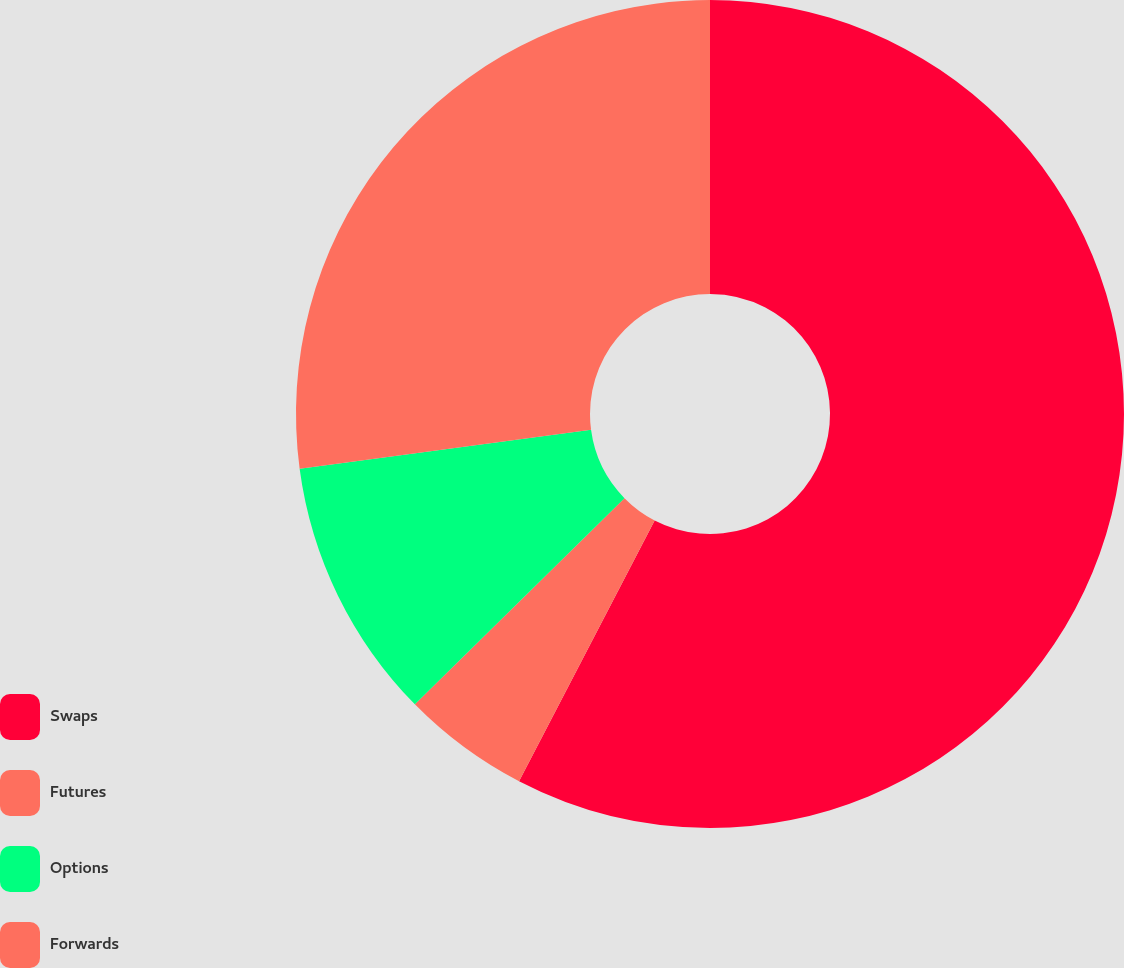Convert chart. <chart><loc_0><loc_0><loc_500><loc_500><pie_chart><fcel>Swaps<fcel>Futures<fcel>Options<fcel>Forwards<nl><fcel>57.63%<fcel>5.0%<fcel>10.26%<fcel>27.11%<nl></chart> 